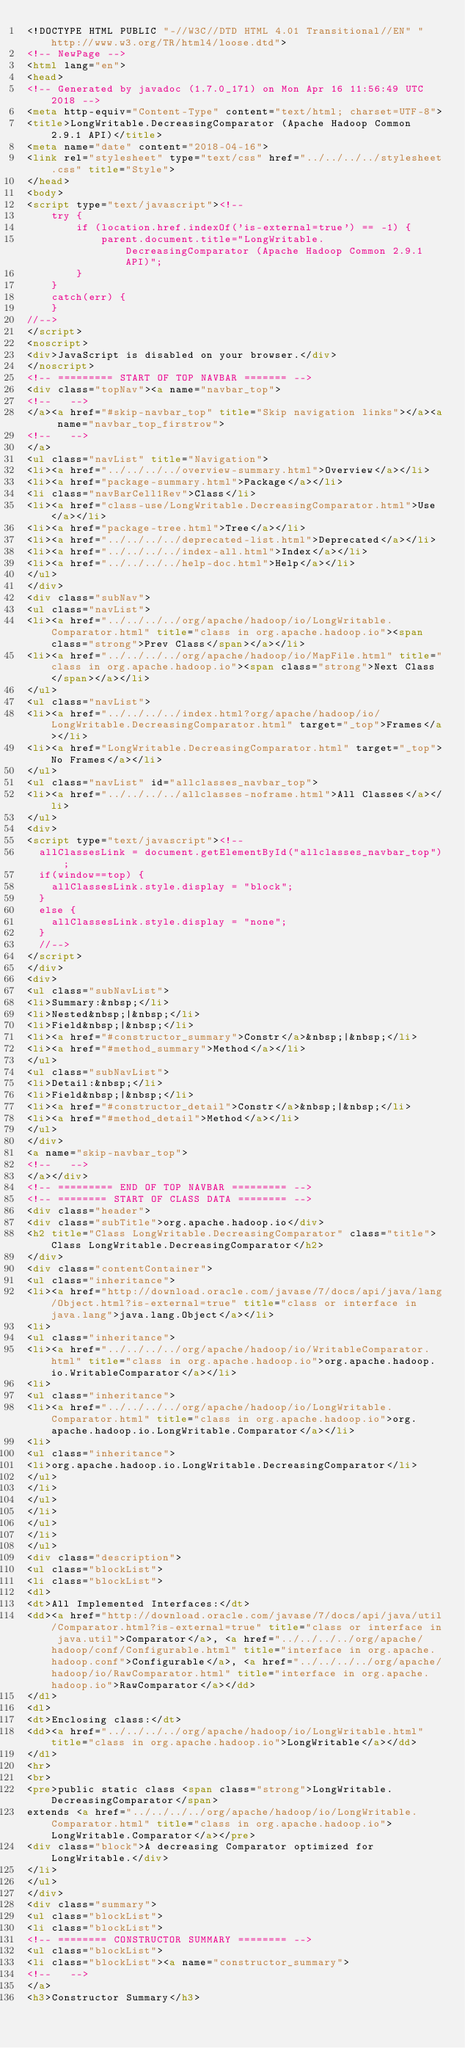<code> <loc_0><loc_0><loc_500><loc_500><_HTML_><!DOCTYPE HTML PUBLIC "-//W3C//DTD HTML 4.01 Transitional//EN" "http://www.w3.org/TR/html4/loose.dtd">
<!-- NewPage -->
<html lang="en">
<head>
<!-- Generated by javadoc (1.7.0_171) on Mon Apr 16 11:56:49 UTC 2018 -->
<meta http-equiv="Content-Type" content="text/html; charset=UTF-8">
<title>LongWritable.DecreasingComparator (Apache Hadoop Common 2.9.1 API)</title>
<meta name="date" content="2018-04-16">
<link rel="stylesheet" type="text/css" href="../../../../stylesheet.css" title="Style">
</head>
<body>
<script type="text/javascript"><!--
    try {
        if (location.href.indexOf('is-external=true') == -1) {
            parent.document.title="LongWritable.DecreasingComparator (Apache Hadoop Common 2.9.1 API)";
        }
    }
    catch(err) {
    }
//-->
</script>
<noscript>
<div>JavaScript is disabled on your browser.</div>
</noscript>
<!-- ========= START OF TOP NAVBAR ======= -->
<div class="topNav"><a name="navbar_top">
<!--   -->
</a><a href="#skip-navbar_top" title="Skip navigation links"></a><a name="navbar_top_firstrow">
<!--   -->
</a>
<ul class="navList" title="Navigation">
<li><a href="../../../../overview-summary.html">Overview</a></li>
<li><a href="package-summary.html">Package</a></li>
<li class="navBarCell1Rev">Class</li>
<li><a href="class-use/LongWritable.DecreasingComparator.html">Use</a></li>
<li><a href="package-tree.html">Tree</a></li>
<li><a href="../../../../deprecated-list.html">Deprecated</a></li>
<li><a href="../../../../index-all.html">Index</a></li>
<li><a href="../../../../help-doc.html">Help</a></li>
</ul>
</div>
<div class="subNav">
<ul class="navList">
<li><a href="../../../../org/apache/hadoop/io/LongWritable.Comparator.html" title="class in org.apache.hadoop.io"><span class="strong">Prev Class</span></a></li>
<li><a href="../../../../org/apache/hadoop/io/MapFile.html" title="class in org.apache.hadoop.io"><span class="strong">Next Class</span></a></li>
</ul>
<ul class="navList">
<li><a href="../../../../index.html?org/apache/hadoop/io/LongWritable.DecreasingComparator.html" target="_top">Frames</a></li>
<li><a href="LongWritable.DecreasingComparator.html" target="_top">No Frames</a></li>
</ul>
<ul class="navList" id="allclasses_navbar_top">
<li><a href="../../../../allclasses-noframe.html">All Classes</a></li>
</ul>
<div>
<script type="text/javascript"><!--
  allClassesLink = document.getElementById("allclasses_navbar_top");
  if(window==top) {
    allClassesLink.style.display = "block";
  }
  else {
    allClassesLink.style.display = "none";
  }
  //-->
</script>
</div>
<div>
<ul class="subNavList">
<li>Summary:&nbsp;</li>
<li>Nested&nbsp;|&nbsp;</li>
<li>Field&nbsp;|&nbsp;</li>
<li><a href="#constructor_summary">Constr</a>&nbsp;|&nbsp;</li>
<li><a href="#method_summary">Method</a></li>
</ul>
<ul class="subNavList">
<li>Detail:&nbsp;</li>
<li>Field&nbsp;|&nbsp;</li>
<li><a href="#constructor_detail">Constr</a>&nbsp;|&nbsp;</li>
<li><a href="#method_detail">Method</a></li>
</ul>
</div>
<a name="skip-navbar_top">
<!--   -->
</a></div>
<!-- ========= END OF TOP NAVBAR ========= -->
<!-- ======== START OF CLASS DATA ======== -->
<div class="header">
<div class="subTitle">org.apache.hadoop.io</div>
<h2 title="Class LongWritable.DecreasingComparator" class="title">Class LongWritable.DecreasingComparator</h2>
</div>
<div class="contentContainer">
<ul class="inheritance">
<li><a href="http://download.oracle.com/javase/7/docs/api/java/lang/Object.html?is-external=true" title="class or interface in java.lang">java.lang.Object</a></li>
<li>
<ul class="inheritance">
<li><a href="../../../../org/apache/hadoop/io/WritableComparator.html" title="class in org.apache.hadoop.io">org.apache.hadoop.io.WritableComparator</a></li>
<li>
<ul class="inheritance">
<li><a href="../../../../org/apache/hadoop/io/LongWritable.Comparator.html" title="class in org.apache.hadoop.io">org.apache.hadoop.io.LongWritable.Comparator</a></li>
<li>
<ul class="inheritance">
<li>org.apache.hadoop.io.LongWritable.DecreasingComparator</li>
</ul>
</li>
</ul>
</li>
</ul>
</li>
</ul>
<div class="description">
<ul class="blockList">
<li class="blockList">
<dl>
<dt>All Implemented Interfaces:</dt>
<dd><a href="http://download.oracle.com/javase/7/docs/api/java/util/Comparator.html?is-external=true" title="class or interface in java.util">Comparator</a>, <a href="../../../../org/apache/hadoop/conf/Configurable.html" title="interface in org.apache.hadoop.conf">Configurable</a>, <a href="../../../../org/apache/hadoop/io/RawComparator.html" title="interface in org.apache.hadoop.io">RawComparator</a></dd>
</dl>
<dl>
<dt>Enclosing class:</dt>
<dd><a href="../../../../org/apache/hadoop/io/LongWritable.html" title="class in org.apache.hadoop.io">LongWritable</a></dd>
</dl>
<hr>
<br>
<pre>public static class <span class="strong">LongWritable.DecreasingComparator</span>
extends <a href="../../../../org/apache/hadoop/io/LongWritable.Comparator.html" title="class in org.apache.hadoop.io">LongWritable.Comparator</a></pre>
<div class="block">A decreasing Comparator optimized for LongWritable.</div>
</li>
</ul>
</div>
<div class="summary">
<ul class="blockList">
<li class="blockList">
<!-- ======== CONSTRUCTOR SUMMARY ======== -->
<ul class="blockList">
<li class="blockList"><a name="constructor_summary">
<!--   -->
</a>
<h3>Constructor Summary</h3></code> 